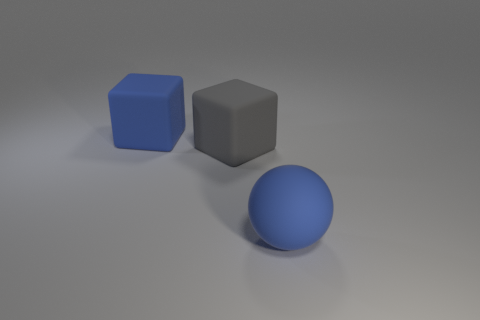How many large balls have the same material as the blue block?
Provide a short and direct response. 1. How many things are yellow cubes or cubes that are to the left of the large gray matte thing?
Your response must be concise. 1. There is a large matte block that is behind the block that is right of the big blue rubber thing behind the blue matte ball; what color is it?
Your answer should be very brief. Blue. How big is the thing in front of the large gray rubber thing?
Give a very brief answer. Large. How many big things are red spheres or balls?
Offer a terse response. 1. There is a rubber object that is both on the left side of the blue rubber sphere and in front of the blue rubber block; what color is it?
Provide a short and direct response. Gray. Is there a shiny object that has the same shape as the large gray rubber thing?
Your answer should be very brief. No. What is the material of the gray object?
Give a very brief answer. Rubber. There is a blue matte ball; are there any blue things right of it?
Make the answer very short. No. How many things are either blue objects right of the gray thing or large rubber objects?
Your answer should be very brief. 3. 